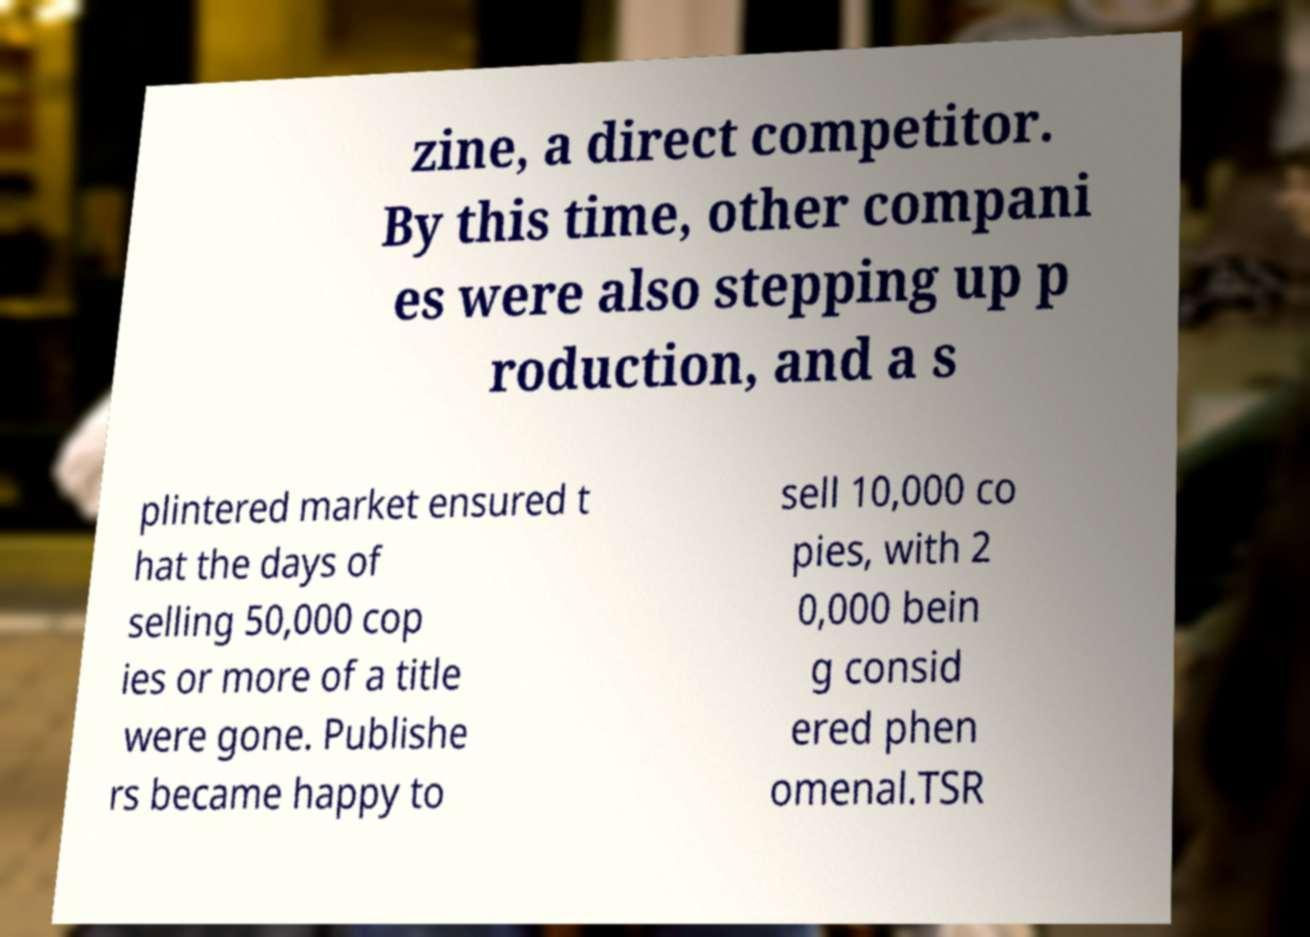Could you assist in decoding the text presented in this image and type it out clearly? zine, a direct competitor. By this time, other compani es were also stepping up p roduction, and a s plintered market ensured t hat the days of selling 50,000 cop ies or more of a title were gone. Publishe rs became happy to sell 10,000 co pies, with 2 0,000 bein g consid ered phen omenal.TSR 